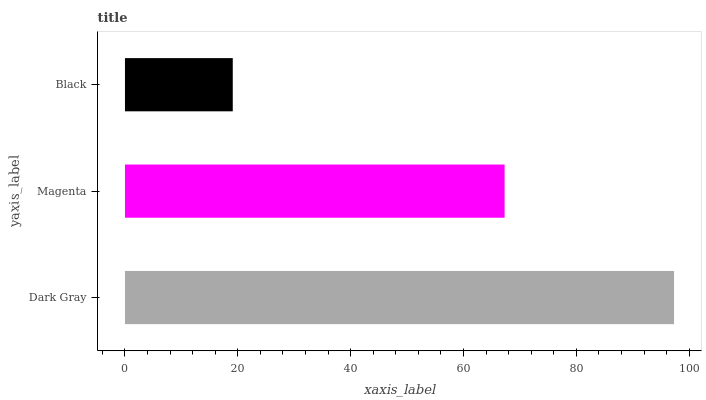Is Black the minimum?
Answer yes or no. Yes. Is Dark Gray the maximum?
Answer yes or no. Yes. Is Magenta the minimum?
Answer yes or no. No. Is Magenta the maximum?
Answer yes or no. No. Is Dark Gray greater than Magenta?
Answer yes or no. Yes. Is Magenta less than Dark Gray?
Answer yes or no. Yes. Is Magenta greater than Dark Gray?
Answer yes or no. No. Is Dark Gray less than Magenta?
Answer yes or no. No. Is Magenta the high median?
Answer yes or no. Yes. Is Magenta the low median?
Answer yes or no. Yes. Is Black the high median?
Answer yes or no. No. Is Black the low median?
Answer yes or no. No. 